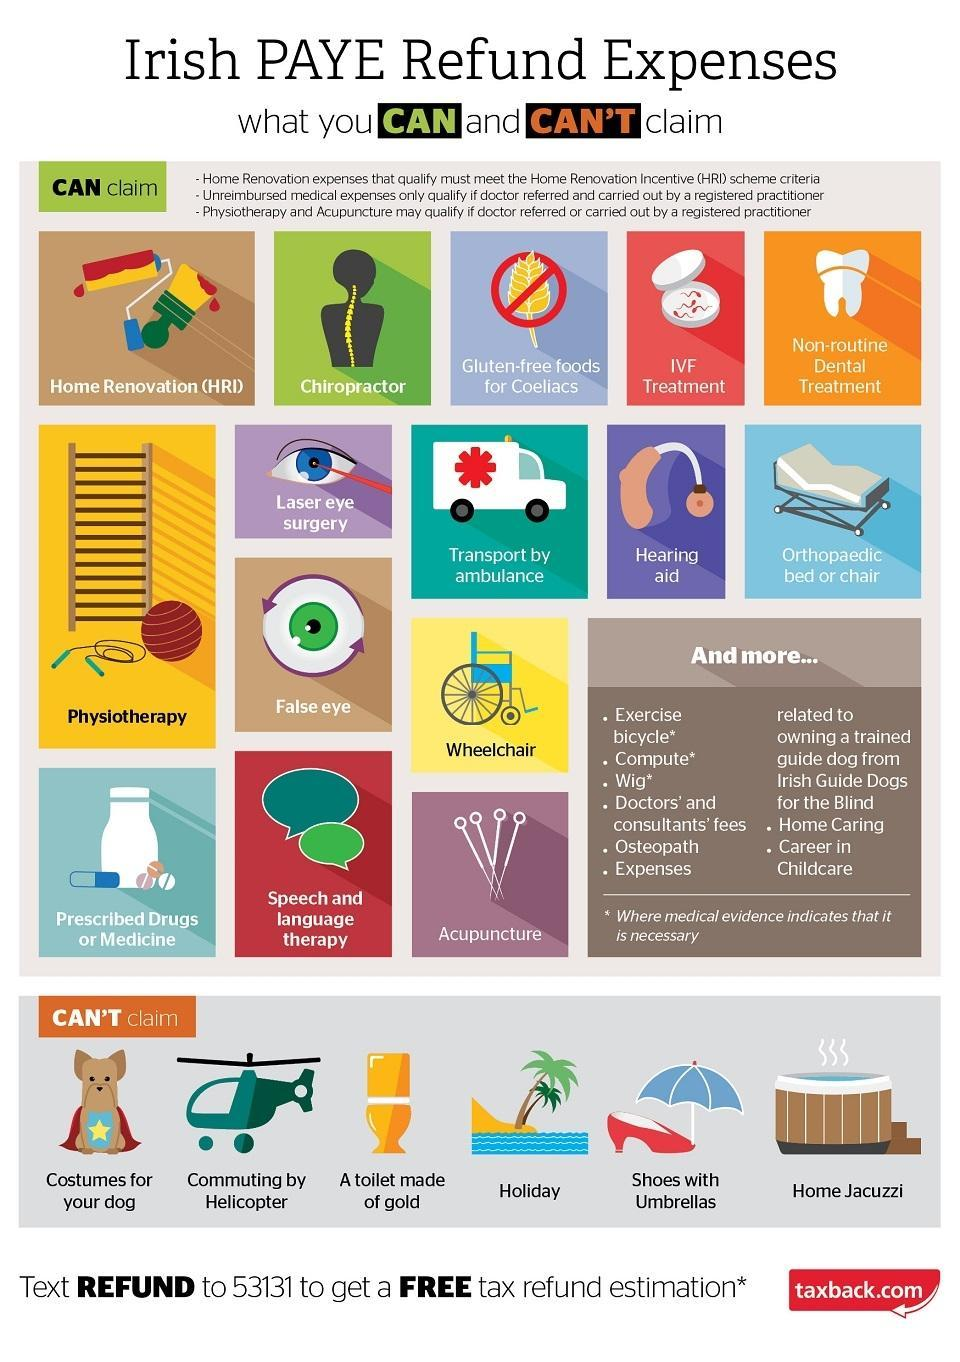Can Irish PAYE refund be claimed for home jacuzzi?
Answer the question with a short phrase. cant claim Can Irish PAYE refund be claimed for Exercise bicycle? can claim 